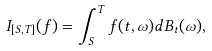<formula> <loc_0><loc_0><loc_500><loc_500>I _ { [ S , T ] } ( f ) = \int ^ { T } _ { S } f ( t , \omega ) d B _ { t } ( \omega ) ,</formula> 